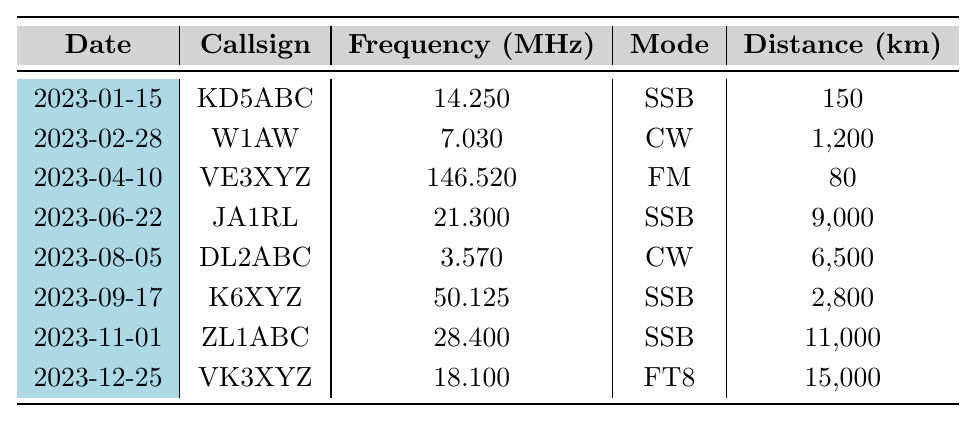What was the frequency used for the contact with callsign KD5ABC? The table shows the entry for KD5ABC on January 15, 2023, and lists the frequency as 14.250 MHz.
Answer: 14.250 MHz How many contacts were made using the CW mode? There are two entries with the mode labeled as CW: W1AW on February 28, 2023, and DL2ABC on August 5, 2023.
Answer: 2 What is the maximum distance covered in the contacts? The table shows the distances for each contact, with VK3XYZ on December 25, 2023, covering the maximum distance of 15,000 km.
Answer: 15,000 km Did the operator contact any stations on FM mode? There is one entry under the mode FM, which is VE3XYZ on April 10, 2023. So, yes, there was a contact made on FM.
Answer: Yes What is the average distance of all contacts made? First, we add all the distances: 150 + 1200 + 80 + 9000 + 6500 + 2800 + 11000 + 15000 = 32030 km. There are 8 contacts, so the average is 32030 / 8 = 4003.75 km.
Answer: 4003.75 km Which contact had the shortest distance traveled? The entry for VE3XYZ dated April 10, 2023, has the shortest distance at 80 km.
Answer: 80 km Was any contact made with a station using a frequency below 4 MHz? The entry for DL2ABC on August 5, 2023, has a frequency of 3.570 MHz, which is below 4 MHz. Thus, there was a contact in this range.
Answer: Yes How many contacts were made on different frequencies above 14 MHz? The entries for JA1RL, ZL1ABC, and VK3XYZ have frequencies of 21.300 MHz, 28.400 MHz, and 18.100 MHz respectively. So, there are three contacts above 14 MHz.
Answer: 3 